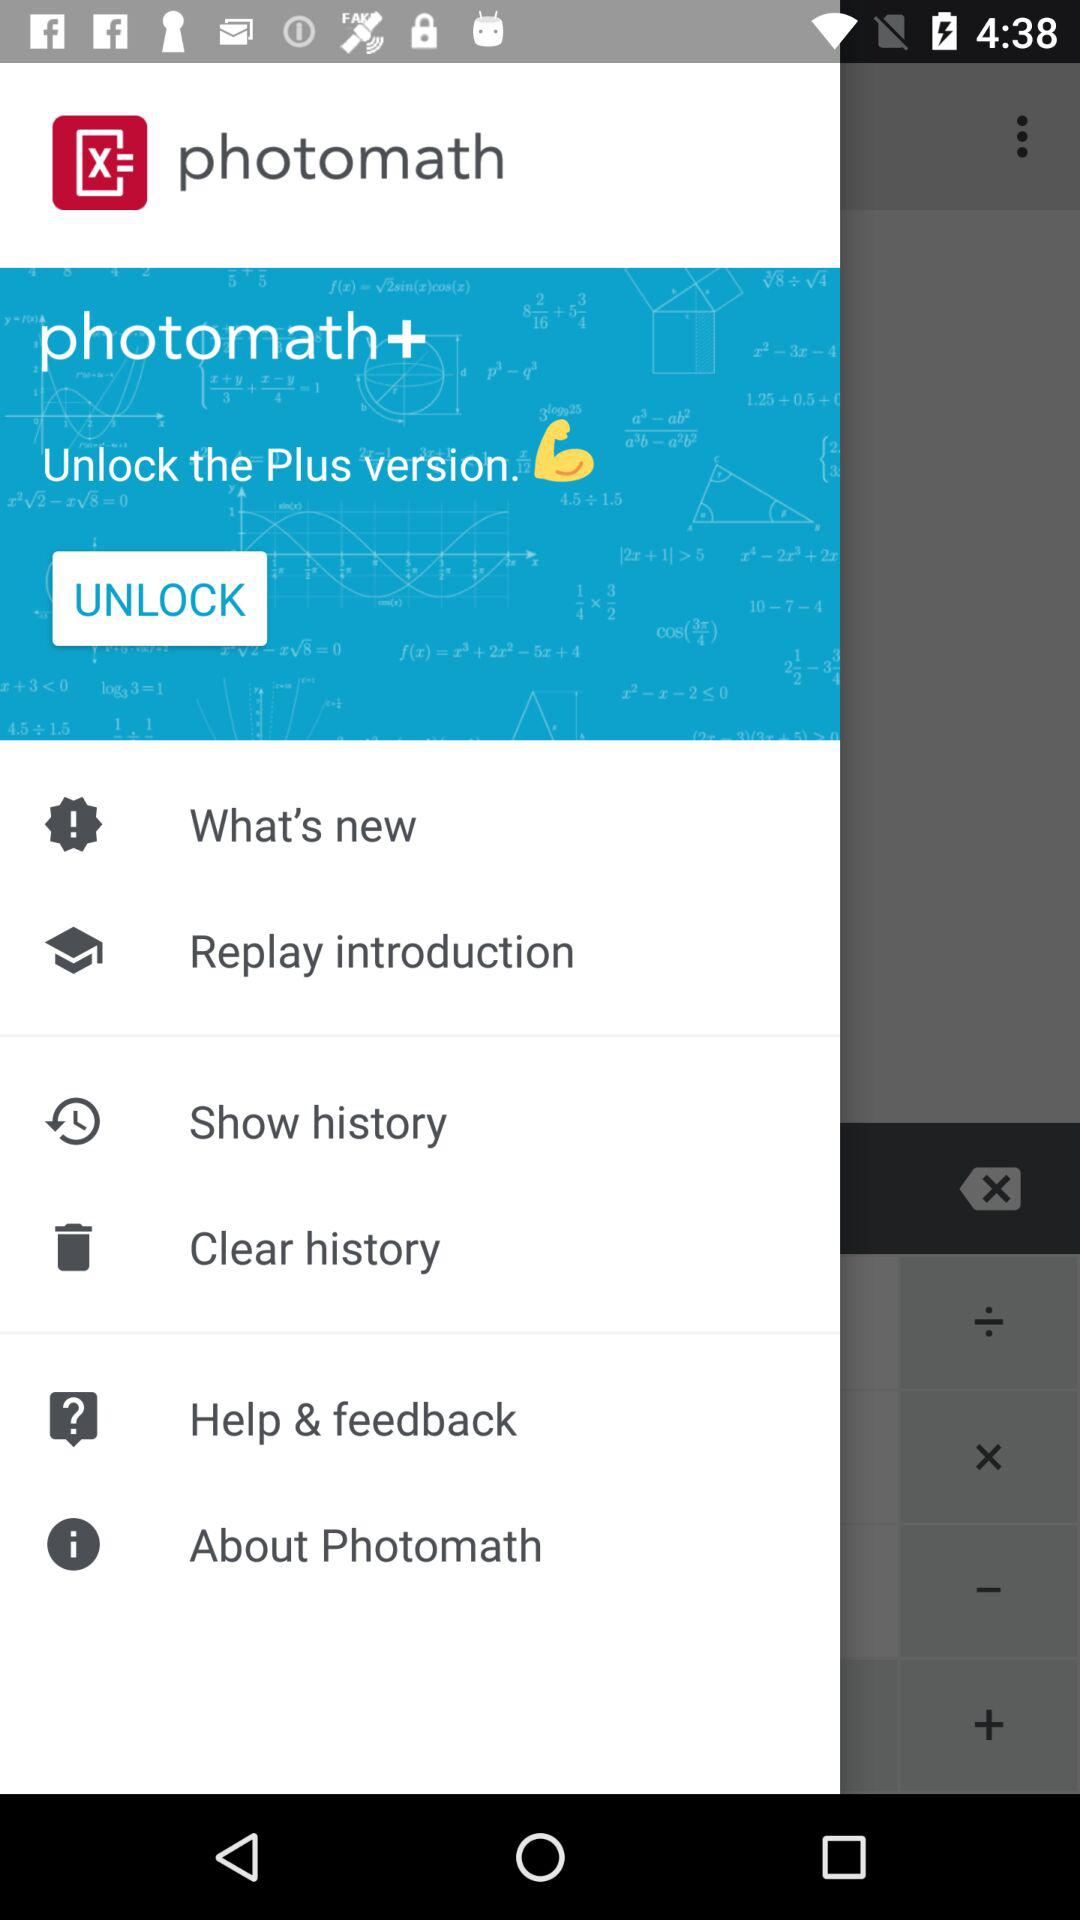What is the application name? The application name is "photomath". 